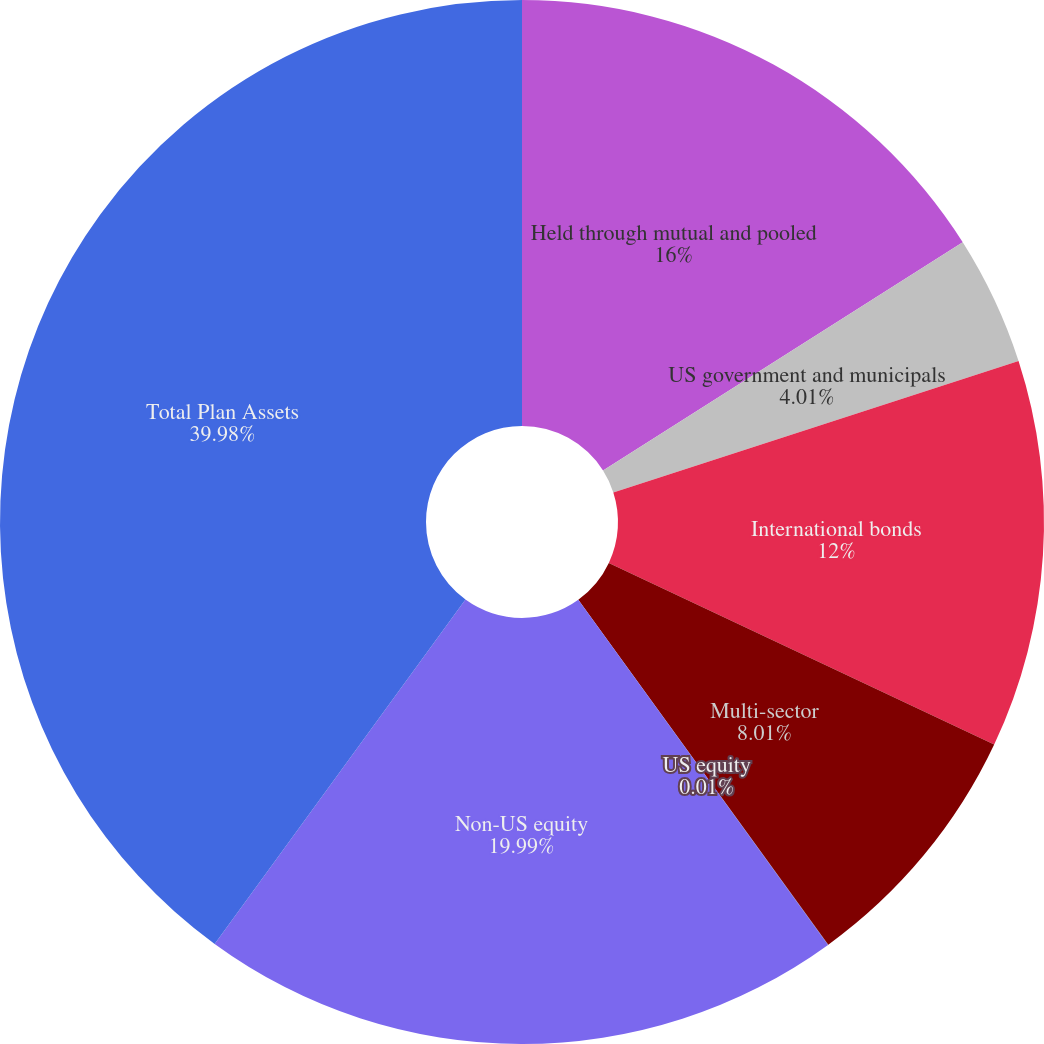Convert chart to OTSL. <chart><loc_0><loc_0><loc_500><loc_500><pie_chart><fcel>Held through mutual and pooled<fcel>US government and municipals<fcel>International bonds<fcel>Multi-sector<fcel>US equity<fcel>Non-US equity<fcel>Total Plan Assets<nl><fcel>16.0%<fcel>4.01%<fcel>12.0%<fcel>8.01%<fcel>0.01%<fcel>19.99%<fcel>39.98%<nl></chart> 